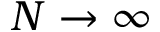<formula> <loc_0><loc_0><loc_500><loc_500>N \rightarrow \infty</formula> 